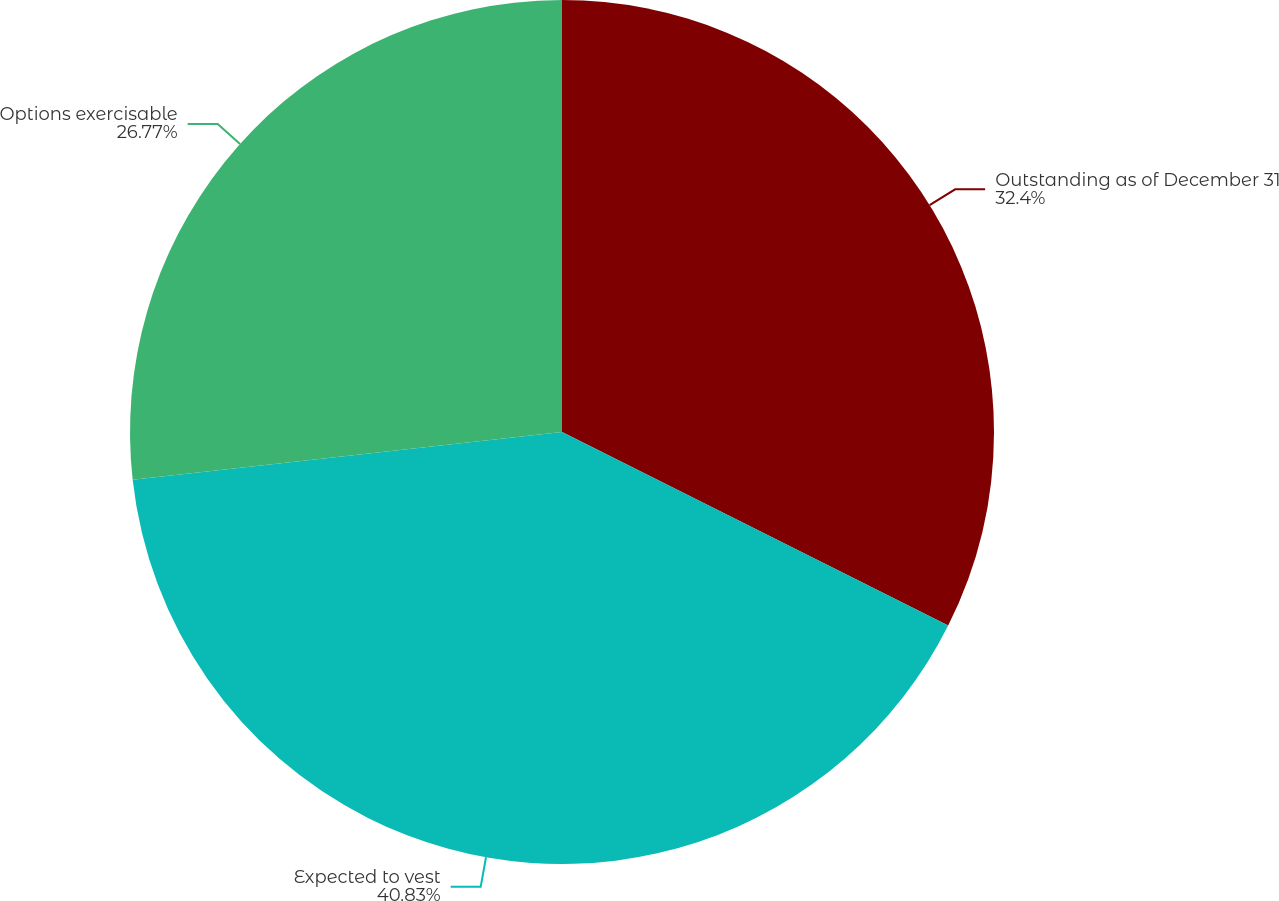Convert chart. <chart><loc_0><loc_0><loc_500><loc_500><pie_chart><fcel>Outstanding as of December 31<fcel>Expected to vest<fcel>Options exercisable<nl><fcel>32.4%<fcel>40.84%<fcel>26.77%<nl></chart> 